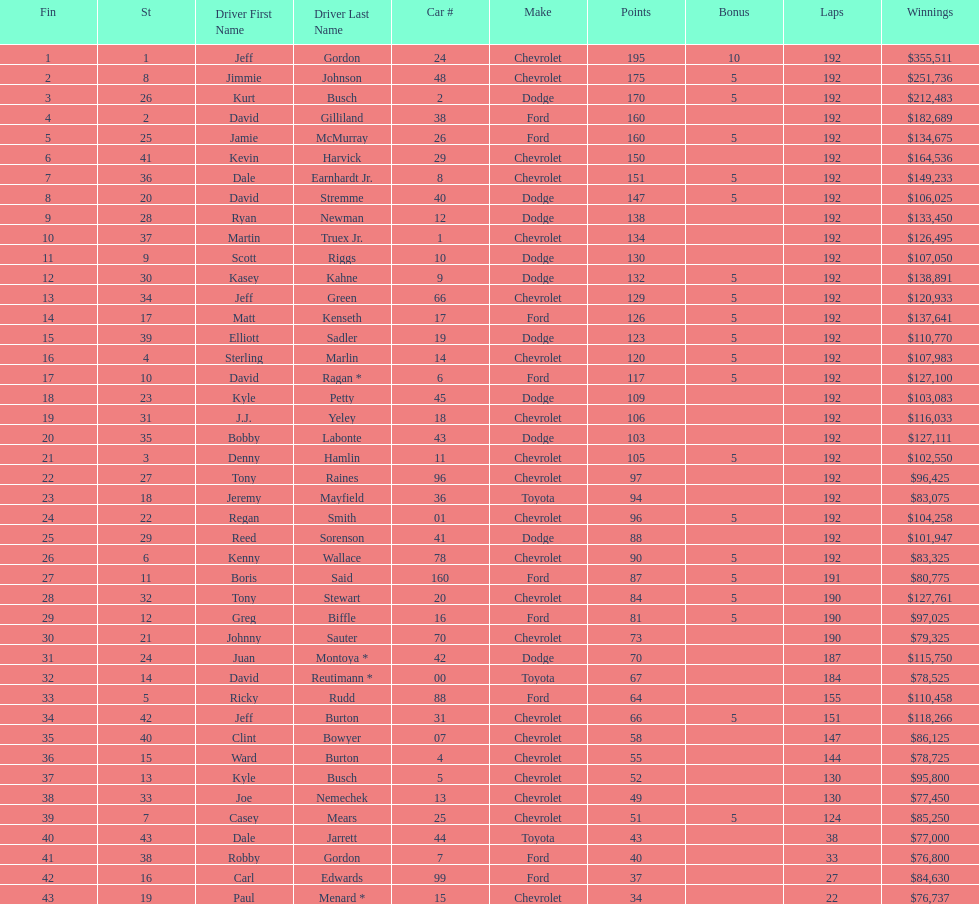What make did kurt busch drive? Dodge. 